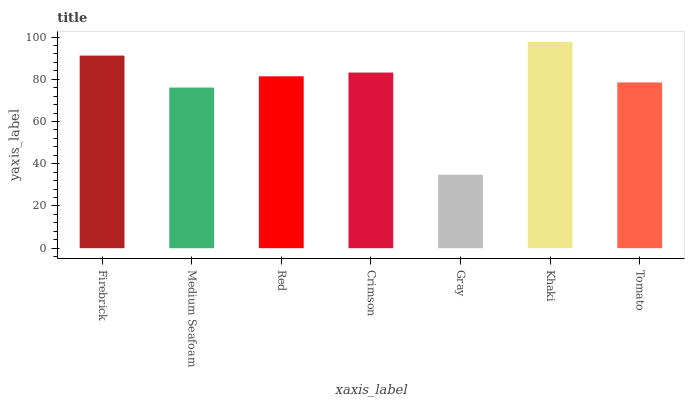Is Gray the minimum?
Answer yes or no. Yes. Is Khaki the maximum?
Answer yes or no. Yes. Is Medium Seafoam the minimum?
Answer yes or no. No. Is Medium Seafoam the maximum?
Answer yes or no. No. Is Firebrick greater than Medium Seafoam?
Answer yes or no. Yes. Is Medium Seafoam less than Firebrick?
Answer yes or no. Yes. Is Medium Seafoam greater than Firebrick?
Answer yes or no. No. Is Firebrick less than Medium Seafoam?
Answer yes or no. No. Is Red the high median?
Answer yes or no. Yes. Is Red the low median?
Answer yes or no. Yes. Is Tomato the high median?
Answer yes or no. No. Is Khaki the low median?
Answer yes or no. No. 